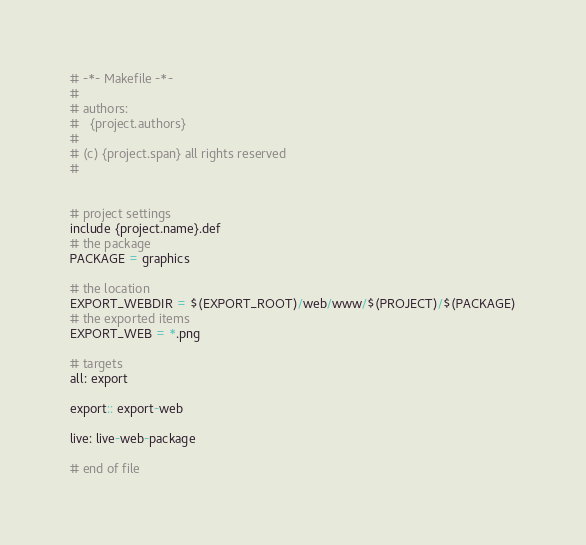<code> <loc_0><loc_0><loc_500><loc_500><_ObjectiveC_># -*- Makefile -*-
#
# authors:
#   {project.authors}
#
# (c) {project.span} all rights reserved
#


# project settings
include {project.name}.def
# the package
PACKAGE = graphics

# the location
EXPORT_WEBDIR = $(EXPORT_ROOT)/web/www/$(PROJECT)/$(PACKAGE)
# the exported items
EXPORT_WEB = *.png

# targets
all: export

export:: export-web

live: live-web-package

# end of file
</code> 